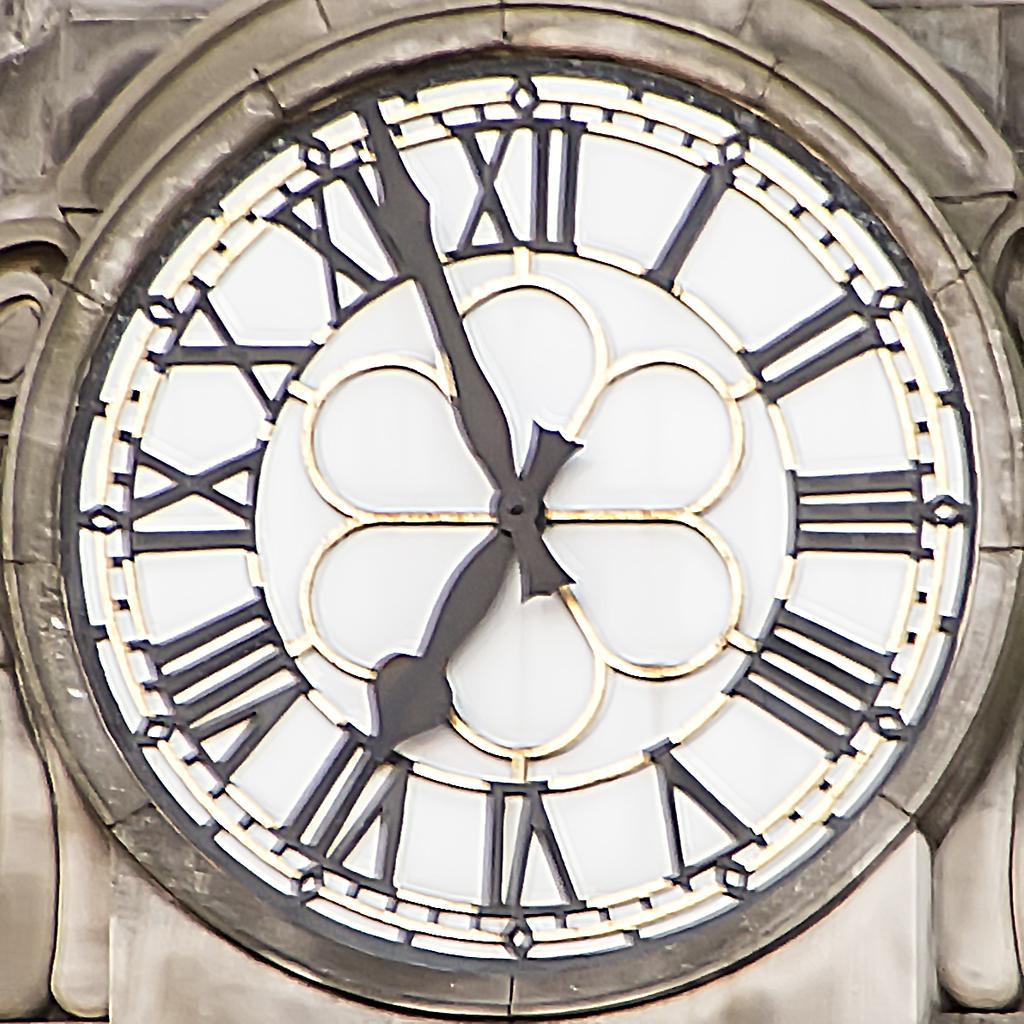Please provide a concise description of this image. In the middle of the image there is a clock on the wall and there are a few carvings on the wall. 